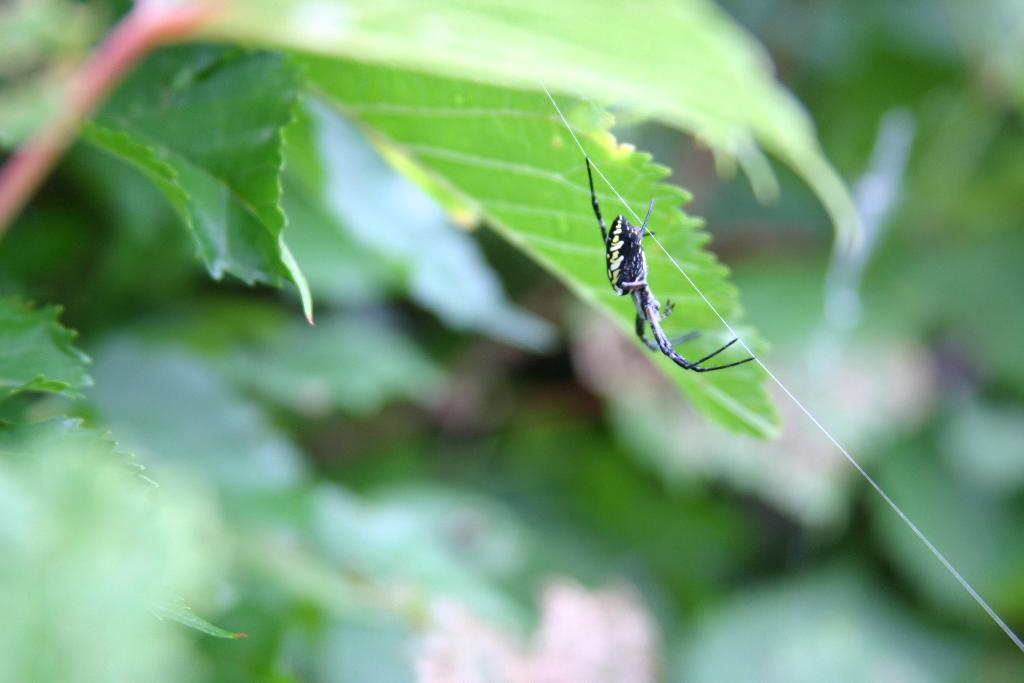What is the main subject of the image? There is a spider in the image. What is the spider doing in the image? The spider is walking on a web. What else can be seen in the image besides the spider? There are plants visible in the image. What type of eggnog is being served in the image? There is no eggnog present in the image; it features a spider walking on a web and plants. 